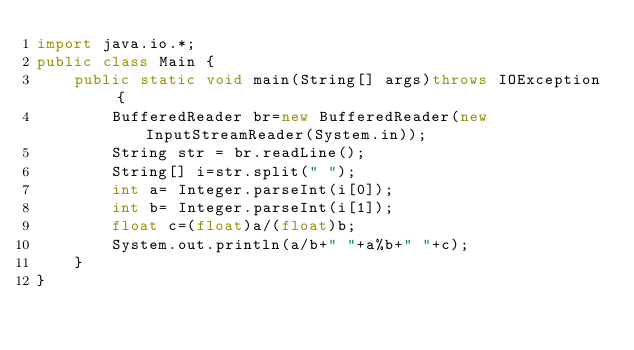<code> <loc_0><loc_0><loc_500><loc_500><_Java_>import java.io.*;
public class Main {
	public static void main(String[] args)throws IOException {
		BufferedReader br=new BufferedReader(new InputStreamReader(System.in));
		String str = br.readLine();
		String[] i=str.split(" ");
		int a= Integer.parseInt(i[0]);
		int b= Integer.parseInt(i[1]);
		float c=(float)a/(float)b;
		System.out.println(a/b+" "+a%b+" "+c);
	}
}</code> 